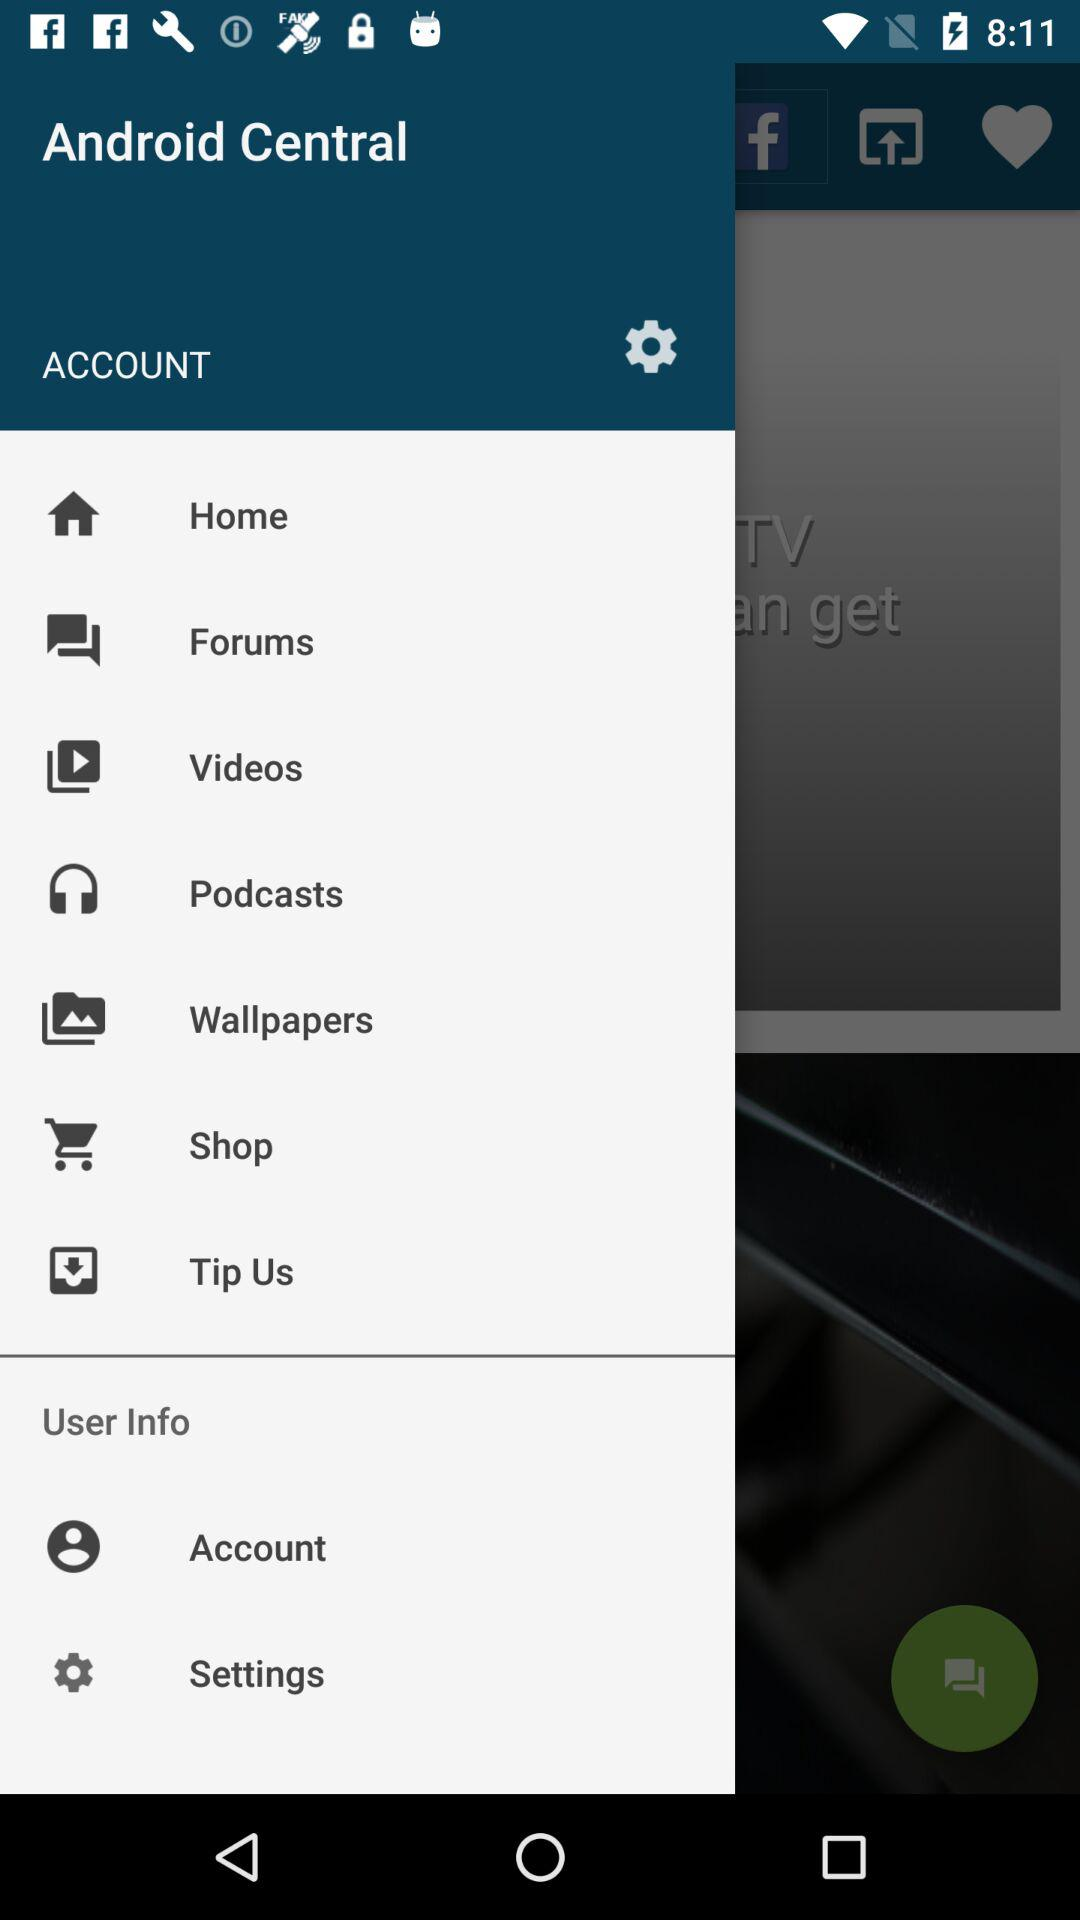What is the application name? The application name is "Android Central". 